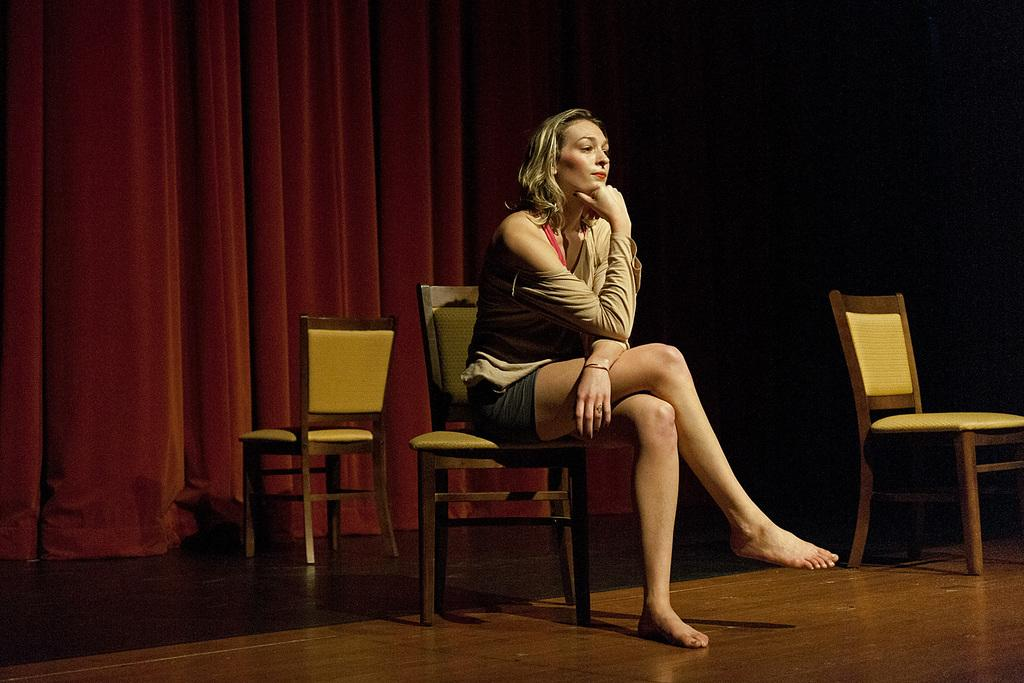Who is present in the image? There is a woman in the image. What is the woman doing in the image? The woman is seated on a chair in the image. What can be seen in the background of the image? There are curtains in the background of the image. What type of structure can be seen in the background of the image? There is no structure visible in the background of the image; only curtains are present. What time of day is it in the image, given the presence of corn? There is no corn present in the image, and therefore the time of day cannot be determined based on its presence. 